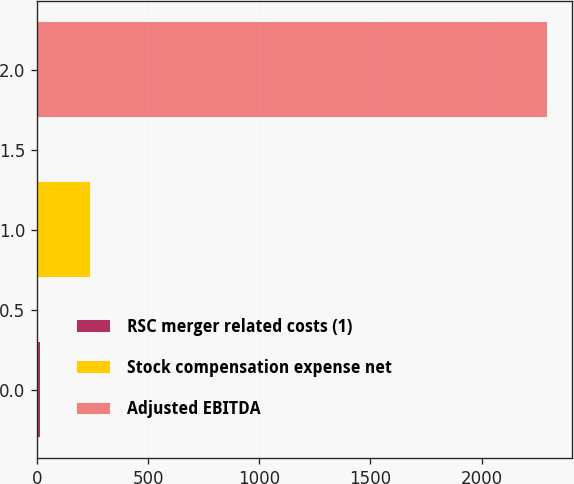<chart> <loc_0><loc_0><loc_500><loc_500><bar_chart><fcel>RSC merger related costs (1)<fcel>Stock compensation expense net<fcel>Adjusted EBITDA<nl><fcel>12<fcel>240.1<fcel>2293<nl></chart> 